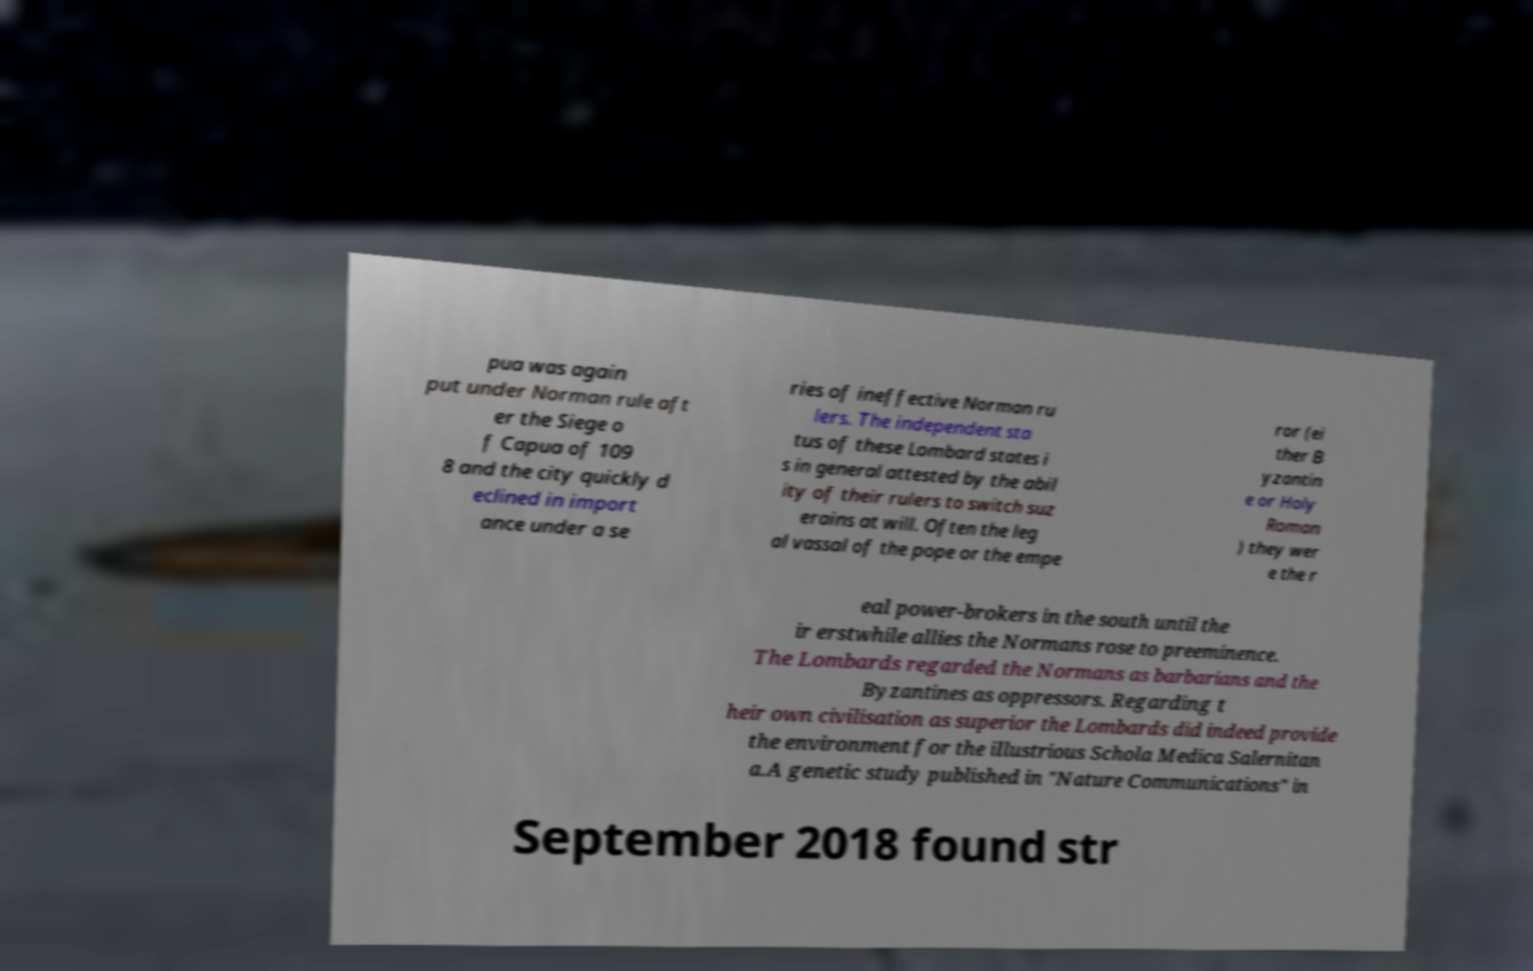Can you read and provide the text displayed in the image?This photo seems to have some interesting text. Can you extract and type it out for me? pua was again put under Norman rule aft er the Siege o f Capua of 109 8 and the city quickly d eclined in import ance under a se ries of ineffective Norman ru lers. The independent sta tus of these Lombard states i s in general attested by the abil ity of their rulers to switch suz erains at will. Often the leg al vassal of the pope or the empe ror (ei ther B yzantin e or Holy Roman ) they wer e the r eal power-brokers in the south until the ir erstwhile allies the Normans rose to preeminence. The Lombards regarded the Normans as barbarians and the Byzantines as oppressors. Regarding t heir own civilisation as superior the Lombards did indeed provide the environment for the illustrious Schola Medica Salernitan a.A genetic study published in "Nature Communications" in September 2018 found str 